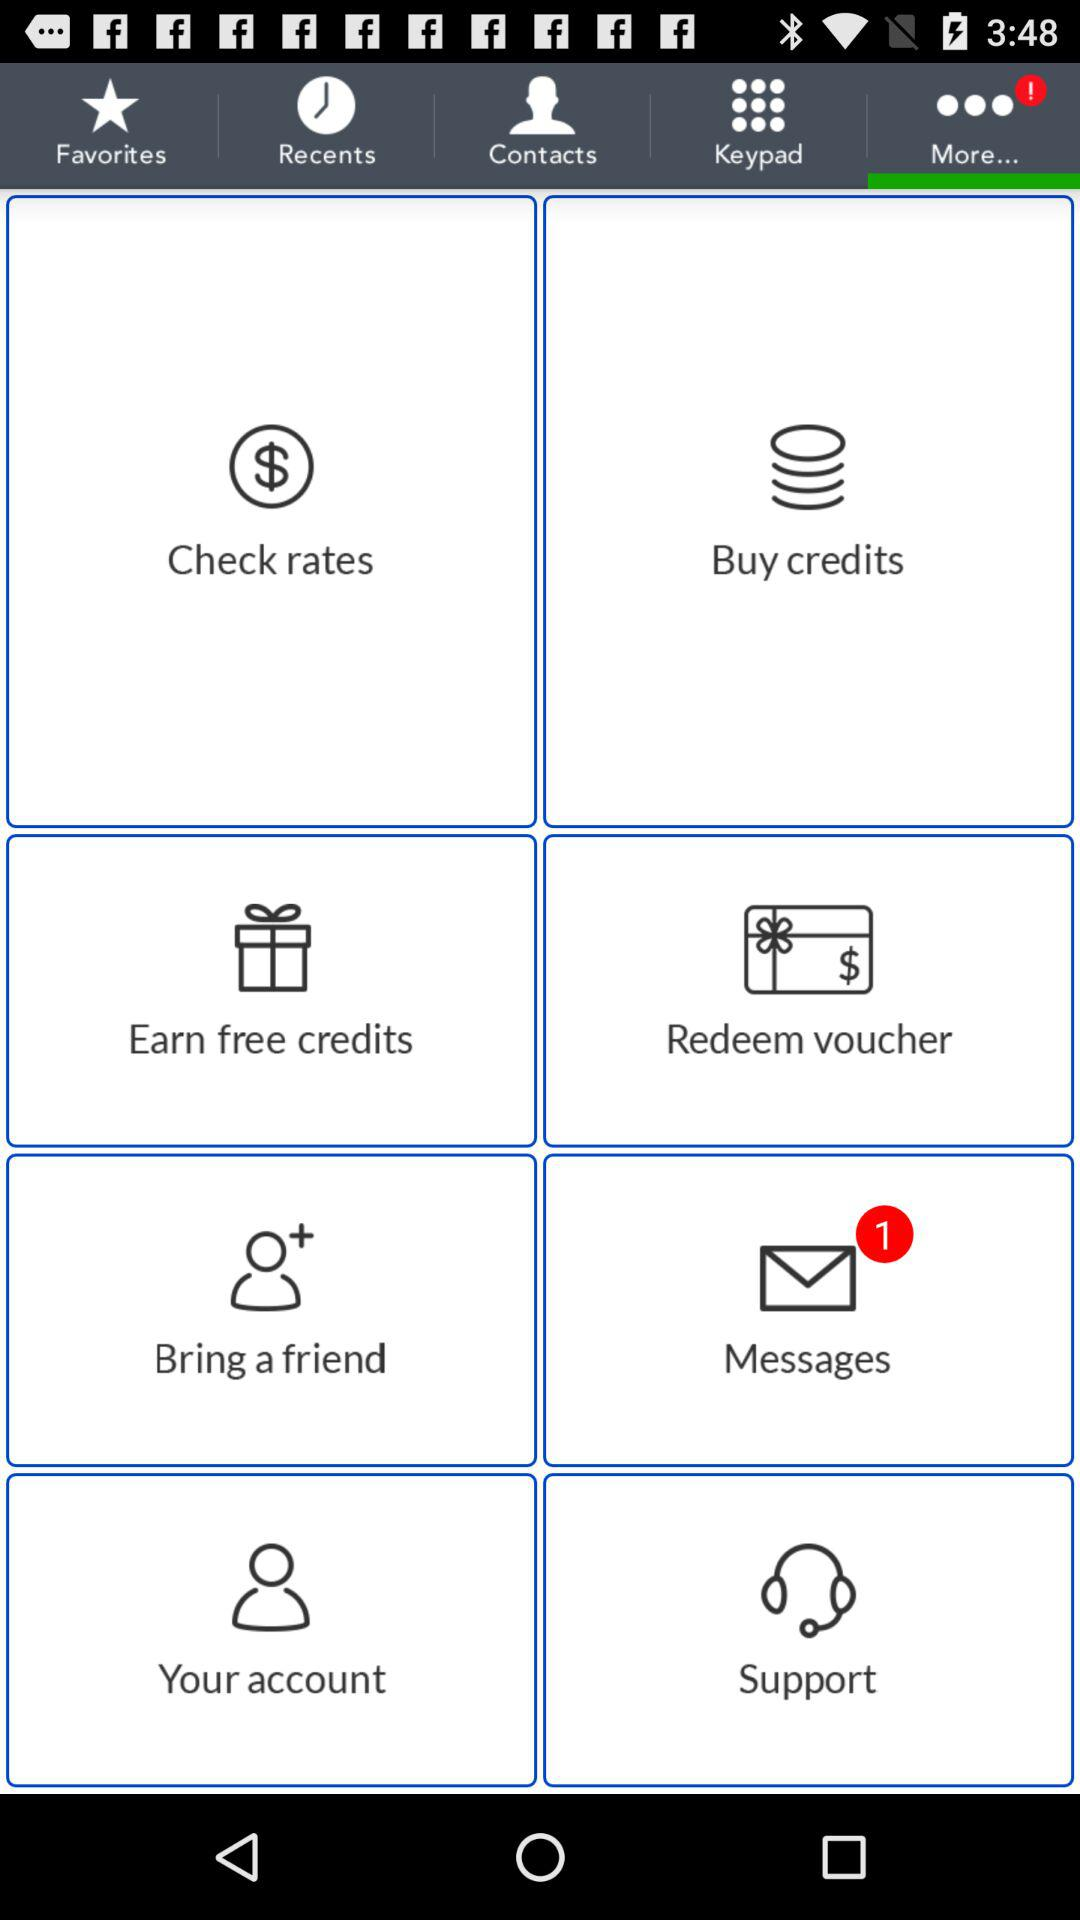What tab is selected? The selected tab is "More...". 